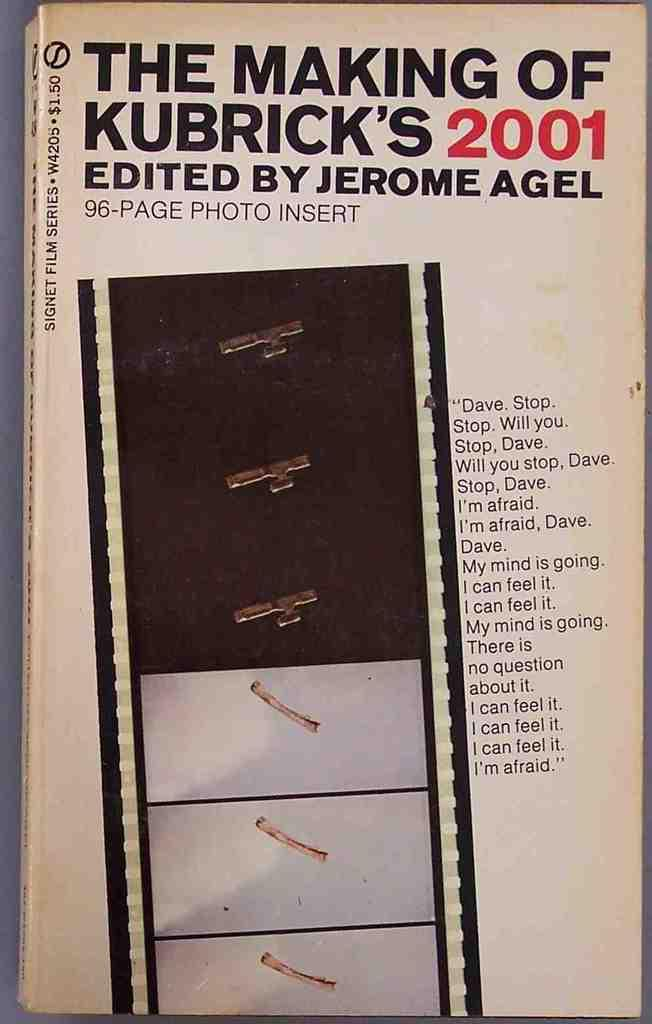What is the main object in the image? There is a book in the image. Can you describe the part of the book that is visible in the image? The image shows the cover page of the book. What type of fruit is depicted on the cover page of the book? There is no fruit depicted on the cover page of the book; it only shows the title and other design elements. 